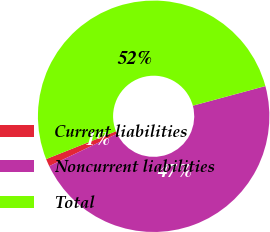<chart> <loc_0><loc_0><loc_500><loc_500><pie_chart><fcel>Current liabilities<fcel>Noncurrent liabilities<fcel>Total<nl><fcel>1.06%<fcel>47.11%<fcel>51.82%<nl></chart> 